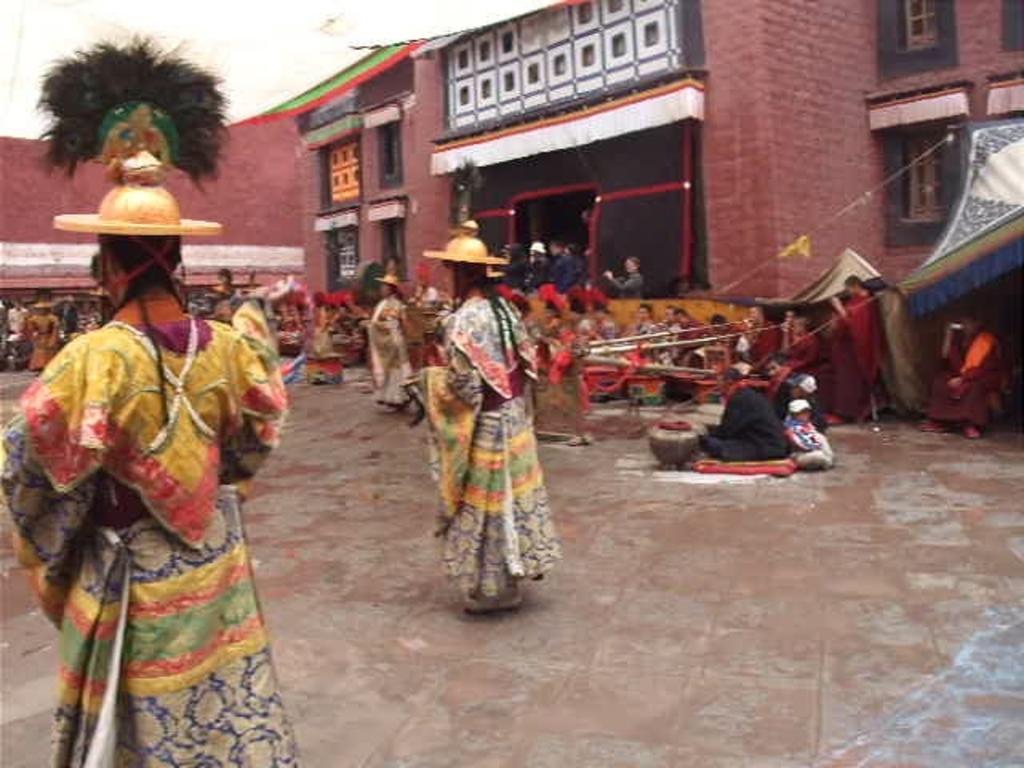Please provide a concise description of this image. In this image, we can see persons in front of the building. There is a tent on the right side of the image. There are three persons wearing clothes and hats. 